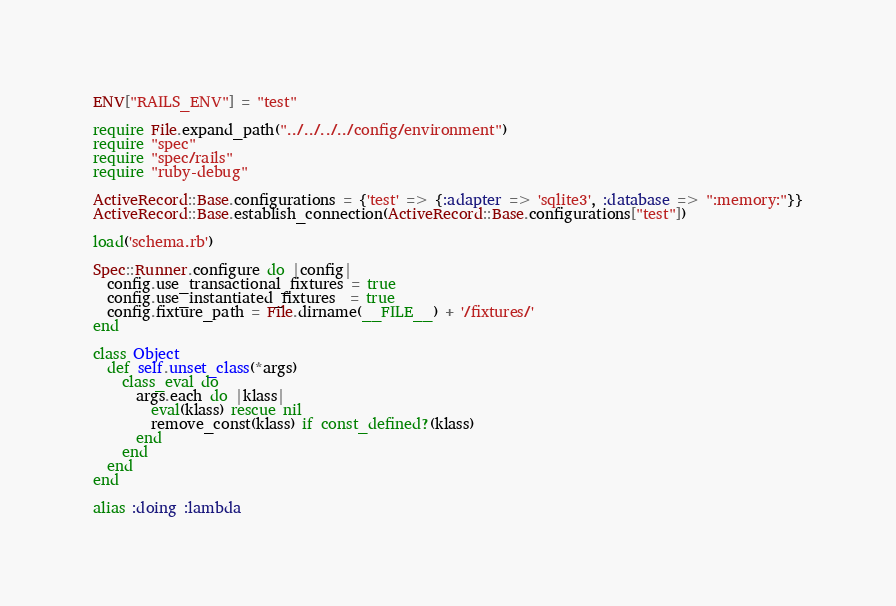<code> <loc_0><loc_0><loc_500><loc_500><_Ruby_>ENV["RAILS_ENV"] = "test"

require File.expand_path("../../../../config/environment")
require "spec"
require "spec/rails"
require "ruby-debug"

ActiveRecord::Base.configurations = {'test' => {:adapter => 'sqlite3', :database => ":memory:"}}
ActiveRecord::Base.establish_connection(ActiveRecord::Base.configurations["test"])

load('schema.rb')

Spec::Runner.configure do |config|
  config.use_transactional_fixtures = true
  config.use_instantiated_fixtures  = true
  config.fixture_path = File.dirname(__FILE__) + '/fixtures/'
end

class Object
  def self.unset_class(*args)
    class_eval do 
      args.each do |klass|
        eval(klass) rescue nil
        remove_const(klass) if const_defined?(klass)
      end
    end
  end
end

alias :doing :lambda</code> 